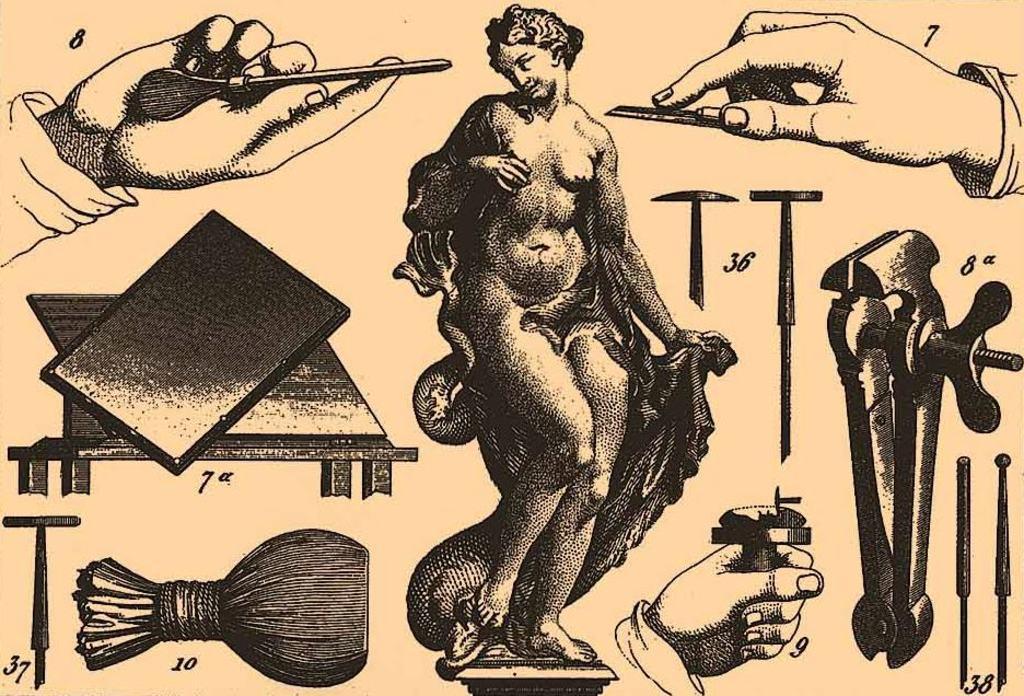How would you summarize this image in a sentence or two? In this image there is a painting, there is a painting of a woman, there are persons hand, there are numbers, there are objects in the person hand, there are objects that looks like tools. 